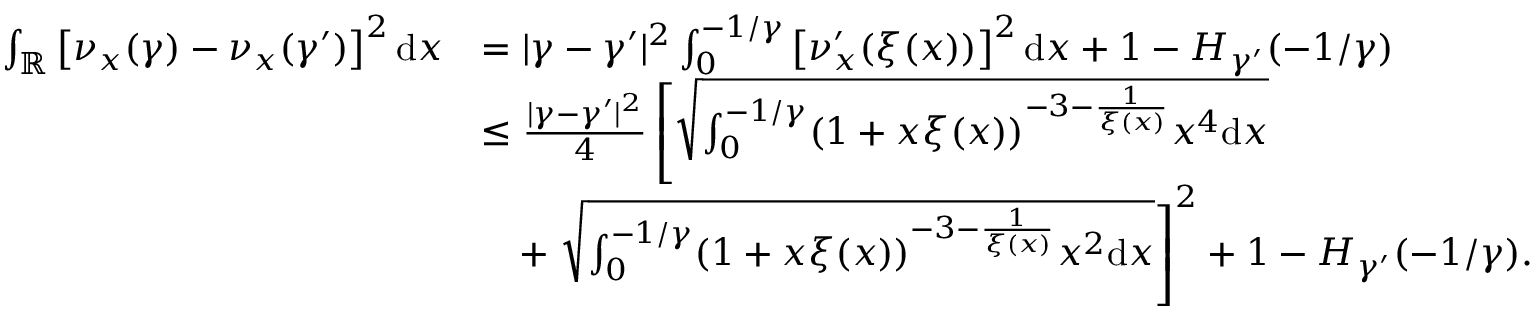<formula> <loc_0><loc_0><loc_500><loc_500>\begin{array} { r l } { \int _ { \mathbb { R } } \left [ \nu _ { x } ( \gamma ) - \nu _ { x } ( \gamma ^ { \prime } ) \right ] ^ { 2 } d x } & { = | \gamma - \gamma ^ { \prime } | ^ { 2 } \int _ { 0 } ^ { - 1 / \gamma } \left [ \nu _ { x } ^ { \prime } ( \xi ( x ) ) \right ] ^ { 2 } d x + 1 - H _ { \gamma ^ { \prime } } ( - 1 / \gamma ) } \\ & { \leq \frac { | \gamma - \gamma ^ { \prime } | ^ { 2 } } { 4 } \left [ \sqrt { \int _ { 0 } ^ { - 1 / \gamma } ( 1 + x \xi ( x ) ) ^ { - 3 - \frac { 1 } { \xi ( x ) } } x ^ { 4 } d x } } \\ & { \quad + \sqrt { \int _ { 0 } ^ { - 1 / \gamma } ( 1 + x \xi ( x ) ) ^ { - 3 - \frac { 1 } { \xi ( x ) } } x ^ { 2 } d x } \right ] ^ { 2 } + 1 - H _ { \gamma ^ { \prime } } ( - 1 / \gamma ) . } \end{array}</formula> 